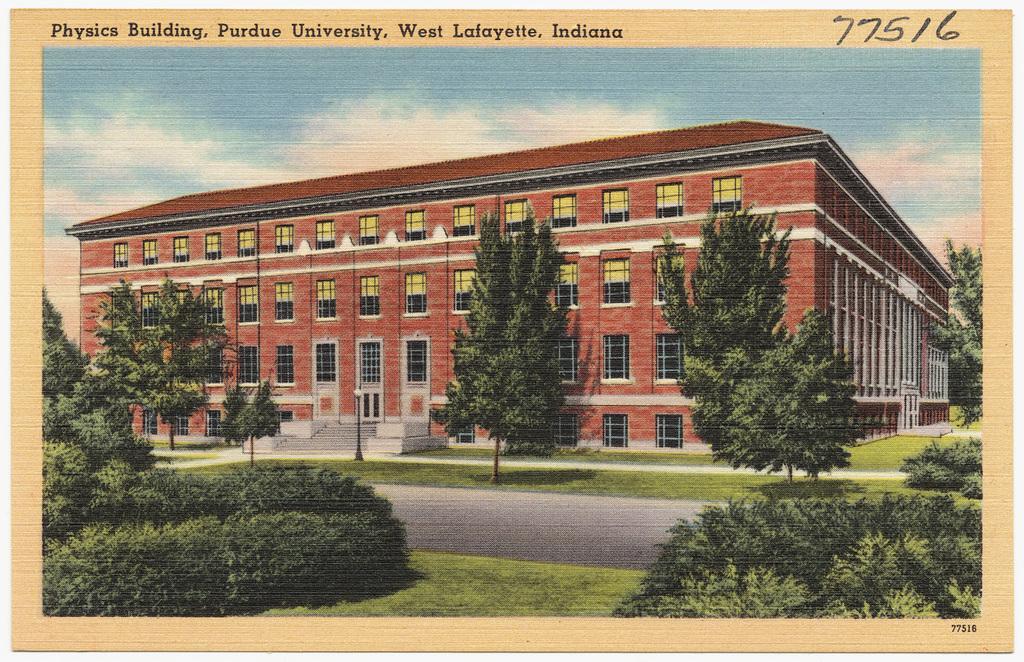How would you summarize this image in a sentence or two? In this picture there is a building and there are few trees in front of it and the ground is greenery and there is something written above the picture. 